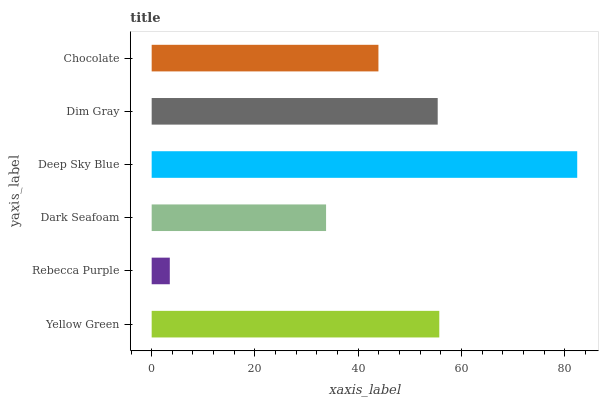Is Rebecca Purple the minimum?
Answer yes or no. Yes. Is Deep Sky Blue the maximum?
Answer yes or no. Yes. Is Dark Seafoam the minimum?
Answer yes or no. No. Is Dark Seafoam the maximum?
Answer yes or no. No. Is Dark Seafoam greater than Rebecca Purple?
Answer yes or no. Yes. Is Rebecca Purple less than Dark Seafoam?
Answer yes or no. Yes. Is Rebecca Purple greater than Dark Seafoam?
Answer yes or no. No. Is Dark Seafoam less than Rebecca Purple?
Answer yes or no. No. Is Dim Gray the high median?
Answer yes or no. Yes. Is Chocolate the low median?
Answer yes or no. Yes. Is Chocolate the high median?
Answer yes or no. No. Is Yellow Green the low median?
Answer yes or no. No. 